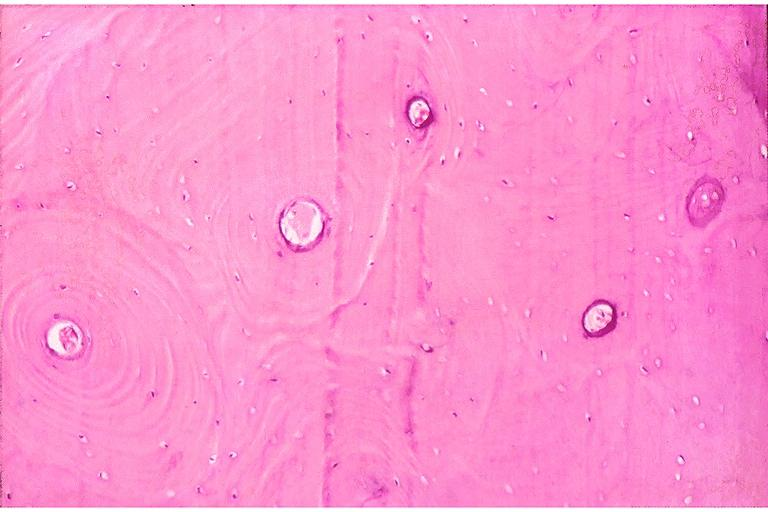does this image show dense sclerotic bone?
Answer the question using a single word or phrase. Yes 